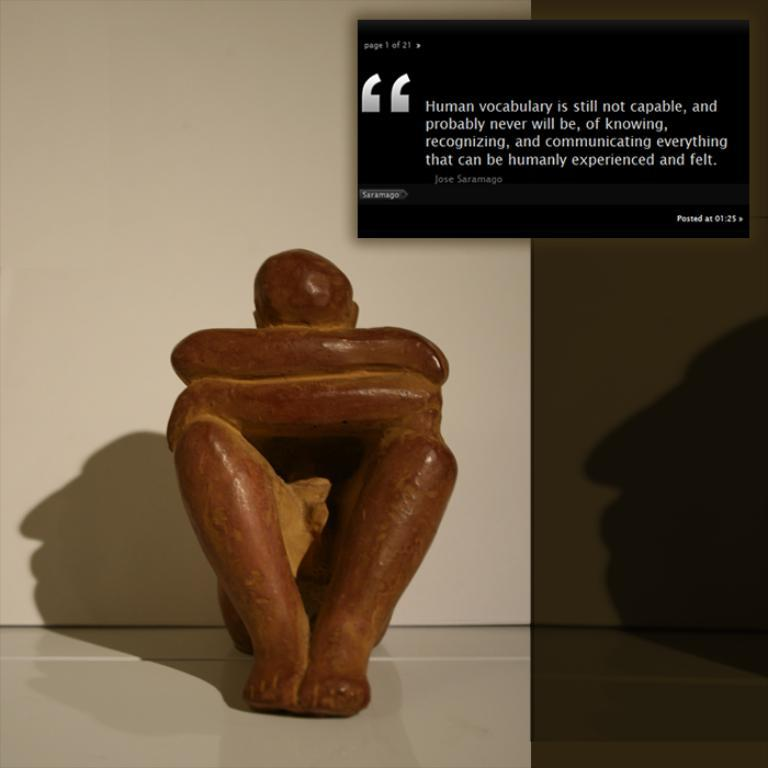What is the main subject of the image? There is a statue in the image. Where is the statue located in the image? The statue is placed on the floor. What type of jeans is the statue wearing in the image? The statue is not wearing jeans, as it is a statue and not a person. 